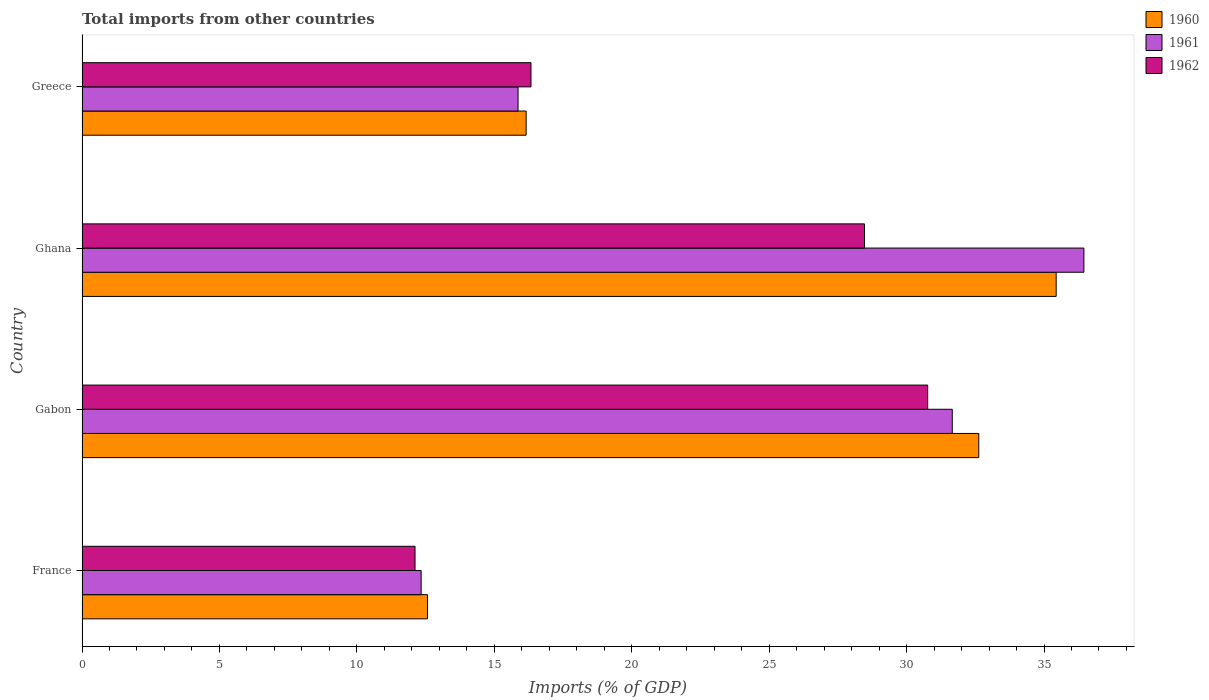Are the number of bars per tick equal to the number of legend labels?
Provide a succinct answer. Yes. What is the label of the 4th group of bars from the top?
Provide a short and direct response. France. What is the total imports in 1960 in Greece?
Your response must be concise. 16.16. Across all countries, what is the maximum total imports in 1962?
Make the answer very short. 30.77. Across all countries, what is the minimum total imports in 1962?
Your answer should be very brief. 12.12. In which country was the total imports in 1961 minimum?
Ensure brevity in your answer.  France. What is the total total imports in 1960 in the graph?
Provide a succinct answer. 96.8. What is the difference between the total imports in 1961 in France and that in Greece?
Offer a very short reply. -3.53. What is the difference between the total imports in 1961 in Greece and the total imports in 1960 in Gabon?
Give a very brief answer. -16.76. What is the average total imports in 1962 per country?
Make the answer very short. 21.92. What is the difference between the total imports in 1961 and total imports in 1960 in Ghana?
Offer a very short reply. 1.01. In how many countries, is the total imports in 1960 greater than 13 %?
Give a very brief answer. 3. What is the ratio of the total imports in 1960 in Ghana to that in Greece?
Keep it short and to the point. 2.19. What is the difference between the highest and the second highest total imports in 1961?
Keep it short and to the point. 4.79. What is the difference between the highest and the lowest total imports in 1960?
Provide a short and direct response. 22.87. In how many countries, is the total imports in 1962 greater than the average total imports in 1962 taken over all countries?
Provide a short and direct response. 2. What does the 3rd bar from the top in Greece represents?
Ensure brevity in your answer.  1960. What does the 3rd bar from the bottom in France represents?
Your response must be concise. 1962. Does the graph contain grids?
Provide a succinct answer. No. Where does the legend appear in the graph?
Your answer should be compact. Top right. How are the legend labels stacked?
Ensure brevity in your answer.  Vertical. What is the title of the graph?
Ensure brevity in your answer.  Total imports from other countries. Does "1977" appear as one of the legend labels in the graph?
Ensure brevity in your answer.  No. What is the label or title of the X-axis?
Ensure brevity in your answer.  Imports (% of GDP). What is the label or title of the Y-axis?
Your response must be concise. Country. What is the Imports (% of GDP) in 1960 in France?
Your answer should be compact. 12.57. What is the Imports (% of GDP) in 1961 in France?
Keep it short and to the point. 12.34. What is the Imports (% of GDP) of 1962 in France?
Offer a very short reply. 12.12. What is the Imports (% of GDP) of 1960 in Gabon?
Give a very brief answer. 32.63. What is the Imports (% of GDP) of 1961 in Gabon?
Your response must be concise. 31.66. What is the Imports (% of GDP) in 1962 in Gabon?
Your answer should be compact. 30.77. What is the Imports (% of GDP) in 1960 in Ghana?
Your answer should be compact. 35.44. What is the Imports (% of GDP) in 1961 in Ghana?
Your answer should be very brief. 36.45. What is the Imports (% of GDP) of 1962 in Ghana?
Your answer should be very brief. 28.47. What is the Imports (% of GDP) of 1960 in Greece?
Your answer should be very brief. 16.16. What is the Imports (% of GDP) in 1961 in Greece?
Provide a short and direct response. 15.86. What is the Imports (% of GDP) of 1962 in Greece?
Keep it short and to the point. 16.33. Across all countries, what is the maximum Imports (% of GDP) in 1960?
Your answer should be compact. 35.44. Across all countries, what is the maximum Imports (% of GDP) of 1961?
Your answer should be compact. 36.45. Across all countries, what is the maximum Imports (% of GDP) of 1962?
Your response must be concise. 30.77. Across all countries, what is the minimum Imports (% of GDP) of 1960?
Offer a very short reply. 12.57. Across all countries, what is the minimum Imports (% of GDP) of 1961?
Provide a short and direct response. 12.34. Across all countries, what is the minimum Imports (% of GDP) of 1962?
Provide a succinct answer. 12.12. What is the total Imports (% of GDP) in 1960 in the graph?
Give a very brief answer. 96.8. What is the total Imports (% of GDP) in 1961 in the graph?
Provide a succinct answer. 96.32. What is the total Imports (% of GDP) in 1962 in the graph?
Provide a succinct answer. 87.69. What is the difference between the Imports (% of GDP) of 1960 in France and that in Gabon?
Offer a very short reply. -20.06. What is the difference between the Imports (% of GDP) of 1961 in France and that in Gabon?
Offer a very short reply. -19.32. What is the difference between the Imports (% of GDP) of 1962 in France and that in Gabon?
Ensure brevity in your answer.  -18.65. What is the difference between the Imports (% of GDP) in 1960 in France and that in Ghana?
Give a very brief answer. -22.87. What is the difference between the Imports (% of GDP) of 1961 in France and that in Ghana?
Your answer should be compact. -24.11. What is the difference between the Imports (% of GDP) of 1962 in France and that in Ghana?
Make the answer very short. -16.35. What is the difference between the Imports (% of GDP) of 1960 in France and that in Greece?
Your answer should be very brief. -3.59. What is the difference between the Imports (% of GDP) of 1961 in France and that in Greece?
Your answer should be compact. -3.53. What is the difference between the Imports (% of GDP) of 1962 in France and that in Greece?
Ensure brevity in your answer.  -4.22. What is the difference between the Imports (% of GDP) in 1960 in Gabon and that in Ghana?
Make the answer very short. -2.82. What is the difference between the Imports (% of GDP) of 1961 in Gabon and that in Ghana?
Keep it short and to the point. -4.79. What is the difference between the Imports (% of GDP) in 1962 in Gabon and that in Ghana?
Your answer should be compact. 2.3. What is the difference between the Imports (% of GDP) of 1960 in Gabon and that in Greece?
Give a very brief answer. 16.47. What is the difference between the Imports (% of GDP) in 1961 in Gabon and that in Greece?
Provide a succinct answer. 15.8. What is the difference between the Imports (% of GDP) of 1962 in Gabon and that in Greece?
Provide a succinct answer. 14.43. What is the difference between the Imports (% of GDP) in 1960 in Ghana and that in Greece?
Ensure brevity in your answer.  19.28. What is the difference between the Imports (% of GDP) in 1961 in Ghana and that in Greece?
Provide a succinct answer. 20.59. What is the difference between the Imports (% of GDP) in 1962 in Ghana and that in Greece?
Your response must be concise. 12.14. What is the difference between the Imports (% of GDP) in 1960 in France and the Imports (% of GDP) in 1961 in Gabon?
Ensure brevity in your answer.  -19.09. What is the difference between the Imports (% of GDP) of 1960 in France and the Imports (% of GDP) of 1962 in Gabon?
Give a very brief answer. -18.2. What is the difference between the Imports (% of GDP) in 1961 in France and the Imports (% of GDP) in 1962 in Gabon?
Ensure brevity in your answer.  -18.43. What is the difference between the Imports (% of GDP) in 1960 in France and the Imports (% of GDP) in 1961 in Ghana?
Make the answer very short. -23.88. What is the difference between the Imports (% of GDP) of 1960 in France and the Imports (% of GDP) of 1962 in Ghana?
Ensure brevity in your answer.  -15.9. What is the difference between the Imports (% of GDP) of 1961 in France and the Imports (% of GDP) of 1962 in Ghana?
Your answer should be compact. -16.13. What is the difference between the Imports (% of GDP) of 1960 in France and the Imports (% of GDP) of 1961 in Greece?
Your answer should be very brief. -3.3. What is the difference between the Imports (% of GDP) of 1960 in France and the Imports (% of GDP) of 1962 in Greece?
Your response must be concise. -3.77. What is the difference between the Imports (% of GDP) of 1961 in France and the Imports (% of GDP) of 1962 in Greece?
Keep it short and to the point. -4. What is the difference between the Imports (% of GDP) of 1960 in Gabon and the Imports (% of GDP) of 1961 in Ghana?
Provide a short and direct response. -3.82. What is the difference between the Imports (% of GDP) of 1960 in Gabon and the Imports (% of GDP) of 1962 in Ghana?
Keep it short and to the point. 4.16. What is the difference between the Imports (% of GDP) in 1961 in Gabon and the Imports (% of GDP) in 1962 in Ghana?
Your answer should be very brief. 3.19. What is the difference between the Imports (% of GDP) of 1960 in Gabon and the Imports (% of GDP) of 1961 in Greece?
Your answer should be compact. 16.76. What is the difference between the Imports (% of GDP) in 1960 in Gabon and the Imports (% of GDP) in 1962 in Greece?
Ensure brevity in your answer.  16.29. What is the difference between the Imports (% of GDP) in 1961 in Gabon and the Imports (% of GDP) in 1962 in Greece?
Give a very brief answer. 15.33. What is the difference between the Imports (% of GDP) of 1960 in Ghana and the Imports (% of GDP) of 1961 in Greece?
Your answer should be very brief. 19.58. What is the difference between the Imports (% of GDP) in 1960 in Ghana and the Imports (% of GDP) in 1962 in Greece?
Your response must be concise. 19.11. What is the difference between the Imports (% of GDP) of 1961 in Ghana and the Imports (% of GDP) of 1962 in Greece?
Your response must be concise. 20.12. What is the average Imports (% of GDP) of 1960 per country?
Offer a very short reply. 24.2. What is the average Imports (% of GDP) in 1961 per country?
Provide a succinct answer. 24.08. What is the average Imports (% of GDP) in 1962 per country?
Provide a succinct answer. 21.92. What is the difference between the Imports (% of GDP) of 1960 and Imports (% of GDP) of 1961 in France?
Keep it short and to the point. 0.23. What is the difference between the Imports (% of GDP) of 1960 and Imports (% of GDP) of 1962 in France?
Make the answer very short. 0.45. What is the difference between the Imports (% of GDP) in 1961 and Imports (% of GDP) in 1962 in France?
Make the answer very short. 0.22. What is the difference between the Imports (% of GDP) in 1960 and Imports (% of GDP) in 1961 in Gabon?
Your answer should be compact. 0.96. What is the difference between the Imports (% of GDP) of 1960 and Imports (% of GDP) of 1962 in Gabon?
Your response must be concise. 1.86. What is the difference between the Imports (% of GDP) in 1961 and Imports (% of GDP) in 1962 in Gabon?
Provide a short and direct response. 0.89. What is the difference between the Imports (% of GDP) of 1960 and Imports (% of GDP) of 1961 in Ghana?
Keep it short and to the point. -1.01. What is the difference between the Imports (% of GDP) in 1960 and Imports (% of GDP) in 1962 in Ghana?
Give a very brief answer. 6.97. What is the difference between the Imports (% of GDP) of 1961 and Imports (% of GDP) of 1962 in Ghana?
Offer a very short reply. 7.98. What is the difference between the Imports (% of GDP) of 1960 and Imports (% of GDP) of 1961 in Greece?
Offer a very short reply. 0.29. What is the difference between the Imports (% of GDP) of 1960 and Imports (% of GDP) of 1962 in Greece?
Your answer should be compact. -0.18. What is the difference between the Imports (% of GDP) of 1961 and Imports (% of GDP) of 1962 in Greece?
Make the answer very short. -0.47. What is the ratio of the Imports (% of GDP) of 1960 in France to that in Gabon?
Offer a very short reply. 0.39. What is the ratio of the Imports (% of GDP) of 1961 in France to that in Gabon?
Your answer should be compact. 0.39. What is the ratio of the Imports (% of GDP) of 1962 in France to that in Gabon?
Give a very brief answer. 0.39. What is the ratio of the Imports (% of GDP) in 1960 in France to that in Ghana?
Your response must be concise. 0.35. What is the ratio of the Imports (% of GDP) in 1961 in France to that in Ghana?
Provide a short and direct response. 0.34. What is the ratio of the Imports (% of GDP) of 1962 in France to that in Ghana?
Provide a short and direct response. 0.43. What is the ratio of the Imports (% of GDP) in 1960 in France to that in Greece?
Keep it short and to the point. 0.78. What is the ratio of the Imports (% of GDP) of 1961 in France to that in Greece?
Your response must be concise. 0.78. What is the ratio of the Imports (% of GDP) of 1962 in France to that in Greece?
Keep it short and to the point. 0.74. What is the ratio of the Imports (% of GDP) of 1960 in Gabon to that in Ghana?
Your response must be concise. 0.92. What is the ratio of the Imports (% of GDP) of 1961 in Gabon to that in Ghana?
Ensure brevity in your answer.  0.87. What is the ratio of the Imports (% of GDP) in 1962 in Gabon to that in Ghana?
Ensure brevity in your answer.  1.08. What is the ratio of the Imports (% of GDP) of 1960 in Gabon to that in Greece?
Your answer should be very brief. 2.02. What is the ratio of the Imports (% of GDP) in 1961 in Gabon to that in Greece?
Your response must be concise. 2. What is the ratio of the Imports (% of GDP) in 1962 in Gabon to that in Greece?
Your response must be concise. 1.88. What is the ratio of the Imports (% of GDP) in 1960 in Ghana to that in Greece?
Make the answer very short. 2.19. What is the ratio of the Imports (% of GDP) in 1961 in Ghana to that in Greece?
Your response must be concise. 2.3. What is the ratio of the Imports (% of GDP) in 1962 in Ghana to that in Greece?
Your response must be concise. 1.74. What is the difference between the highest and the second highest Imports (% of GDP) in 1960?
Your answer should be very brief. 2.82. What is the difference between the highest and the second highest Imports (% of GDP) in 1961?
Offer a very short reply. 4.79. What is the difference between the highest and the second highest Imports (% of GDP) of 1962?
Provide a succinct answer. 2.3. What is the difference between the highest and the lowest Imports (% of GDP) of 1960?
Keep it short and to the point. 22.87. What is the difference between the highest and the lowest Imports (% of GDP) in 1961?
Ensure brevity in your answer.  24.11. What is the difference between the highest and the lowest Imports (% of GDP) of 1962?
Make the answer very short. 18.65. 